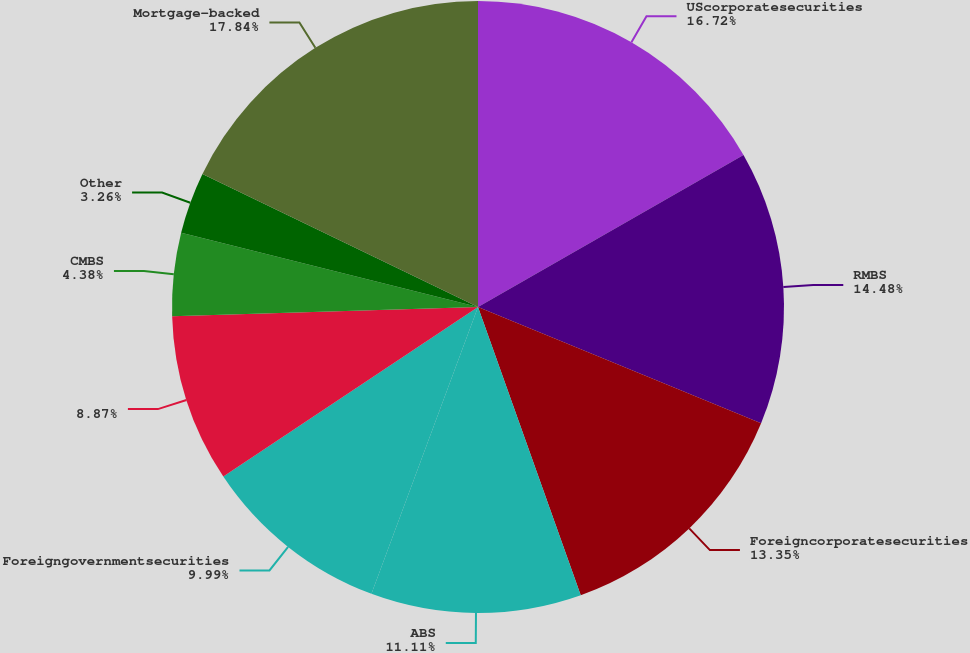Convert chart to OTSL. <chart><loc_0><loc_0><loc_500><loc_500><pie_chart><fcel>UScorporatesecurities<fcel>RMBS<fcel>Foreigncorporatesecurities<fcel>ABS<fcel>Foreigngovernmentsecurities<fcel>Unnamed: 5<fcel>CMBS<fcel>Other<fcel>Mortgage-backed<nl><fcel>16.72%<fcel>14.48%<fcel>13.35%<fcel>11.11%<fcel>9.99%<fcel>8.87%<fcel>4.38%<fcel>3.26%<fcel>17.84%<nl></chart> 